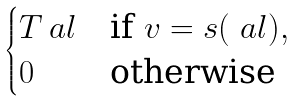Convert formula to latex. <formula><loc_0><loc_0><loc_500><loc_500>\begin{cases} T _ { \ } a l & \text {if } v = s ( \ a l ) , \\ 0 & \text {otherwise} \end{cases}</formula> 